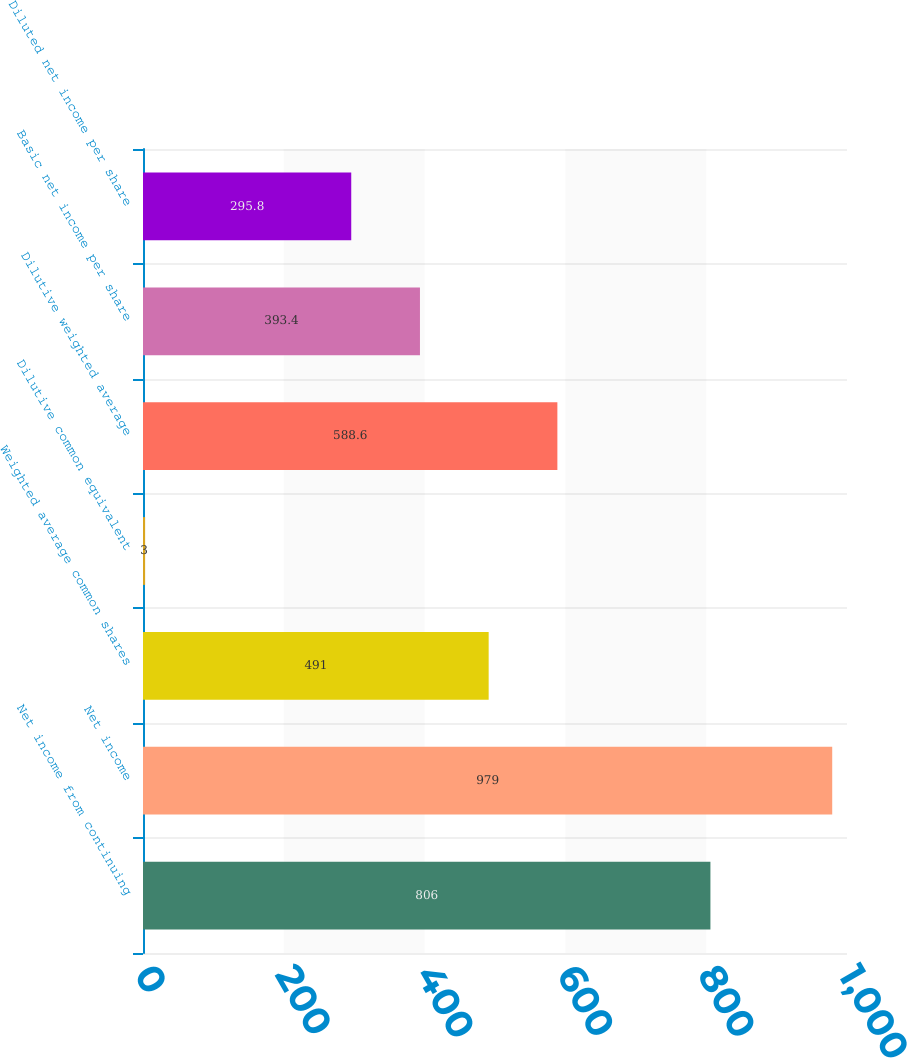Convert chart. <chart><loc_0><loc_0><loc_500><loc_500><bar_chart><fcel>Net income from continuing<fcel>Net income<fcel>Weighted average common shares<fcel>Dilutive common equivalent<fcel>Dilutive weighted average<fcel>Basic net income per share<fcel>Diluted net income per share<nl><fcel>806<fcel>979<fcel>491<fcel>3<fcel>588.6<fcel>393.4<fcel>295.8<nl></chart> 